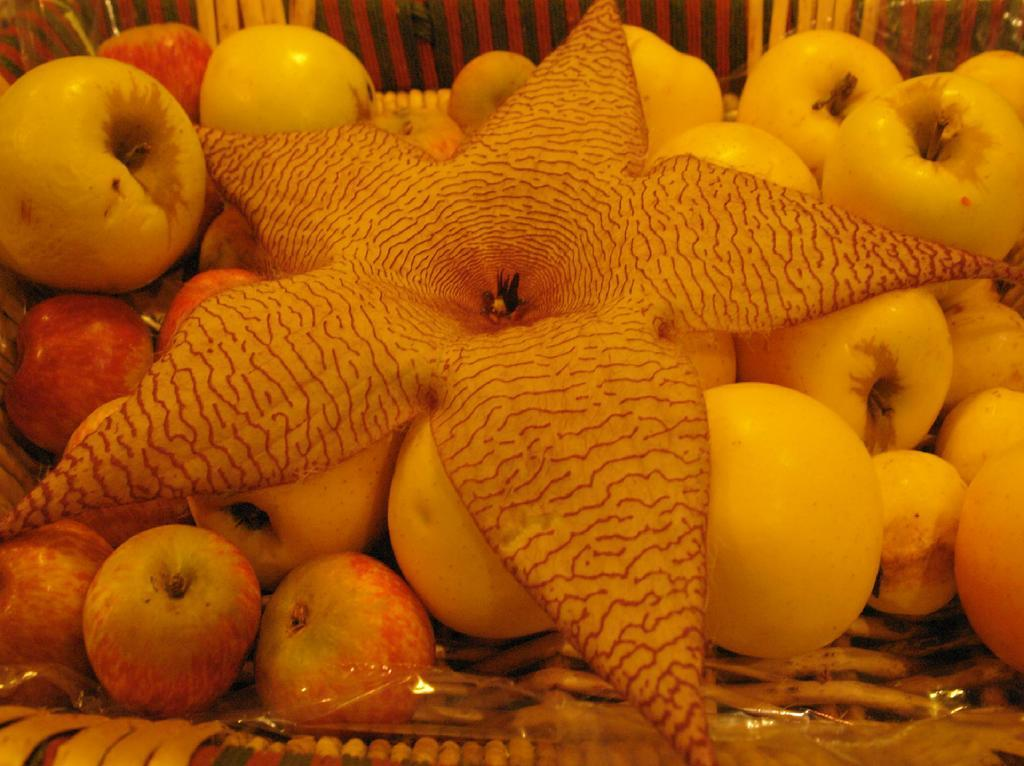What is the main subject of the image? The main subject of the image is a collection of apples. Are there any other objects in the image besides the apples? Yes, there is a flower in the basket with the apples. How are the apples and flower arranged in the image? The apples and flower are arranged in a basket. What type of fowl can be seen sitting on the desk in the image? There is no fowl or desk present in the image; it features a basket with apples and a flower. 